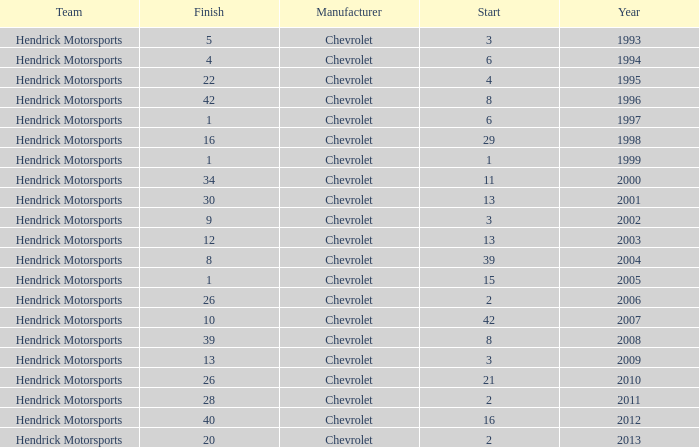Which team had a start of 8 in years under 2008? Hendrick Motorsports. 